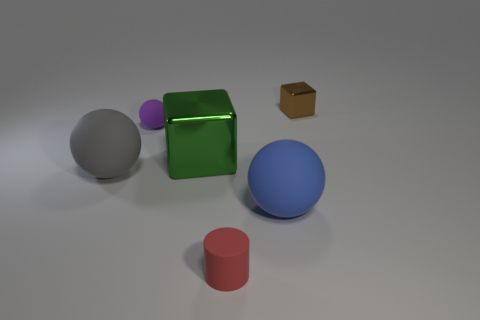There is a big gray object that is the same shape as the purple matte object; what is it made of?
Keep it short and to the point. Rubber. What number of gray matte things are the same size as the green block?
Offer a terse response. 1. The tiny cylinder that is the same material as the blue sphere is what color?
Ensure brevity in your answer.  Red. Are there fewer green spheres than objects?
Give a very brief answer. Yes. How many yellow things are large metallic cylinders or blocks?
Provide a short and direct response. 0. How many large things are in front of the green shiny block and behind the blue sphere?
Your answer should be compact. 1. Does the big blue object have the same material as the purple sphere?
Keep it short and to the point. Yes. There is a red matte thing that is the same size as the brown metallic cube; what is its shape?
Offer a terse response. Cylinder. Is the number of small purple metal things greater than the number of spheres?
Your answer should be very brief. No. What is the thing that is both left of the large metal cube and in front of the green metallic block made of?
Keep it short and to the point. Rubber. 